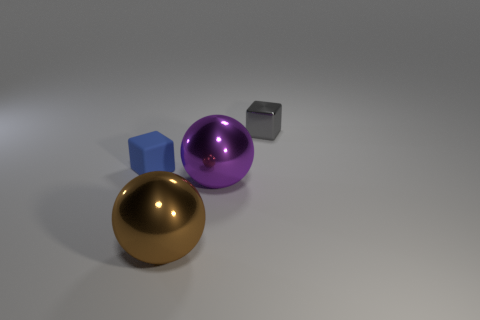How would you describe the texture of the objects? Each object in the image has a distinct texture. The golden sphere looks polished and reflective, imitating a smooth metallic surface. The purple sphere appears to have a matte finish with a slightly soft touch, while the blue cube and the small gray cube both seem to have a flat, non-reflective texture indicative of a solid, possibly plastic material. 